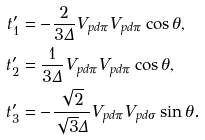Convert formula to latex. <formula><loc_0><loc_0><loc_500><loc_500>t _ { 1 } ^ { \prime } & = - \frac { 2 } { 3 \Delta } V _ { p d \pi } V _ { p d \pi } \cos \theta , \\ t _ { 2 } ^ { \prime } & = \frac { 1 } { 3 \Delta } V _ { p d \pi } V _ { p d \pi } \cos \theta , \\ t _ { 3 } ^ { \prime } & = - \frac { \sqrt { 2 } } { \sqrt { 3 } \Delta } V _ { p d \pi } V _ { p d \sigma } \sin \theta .</formula> 